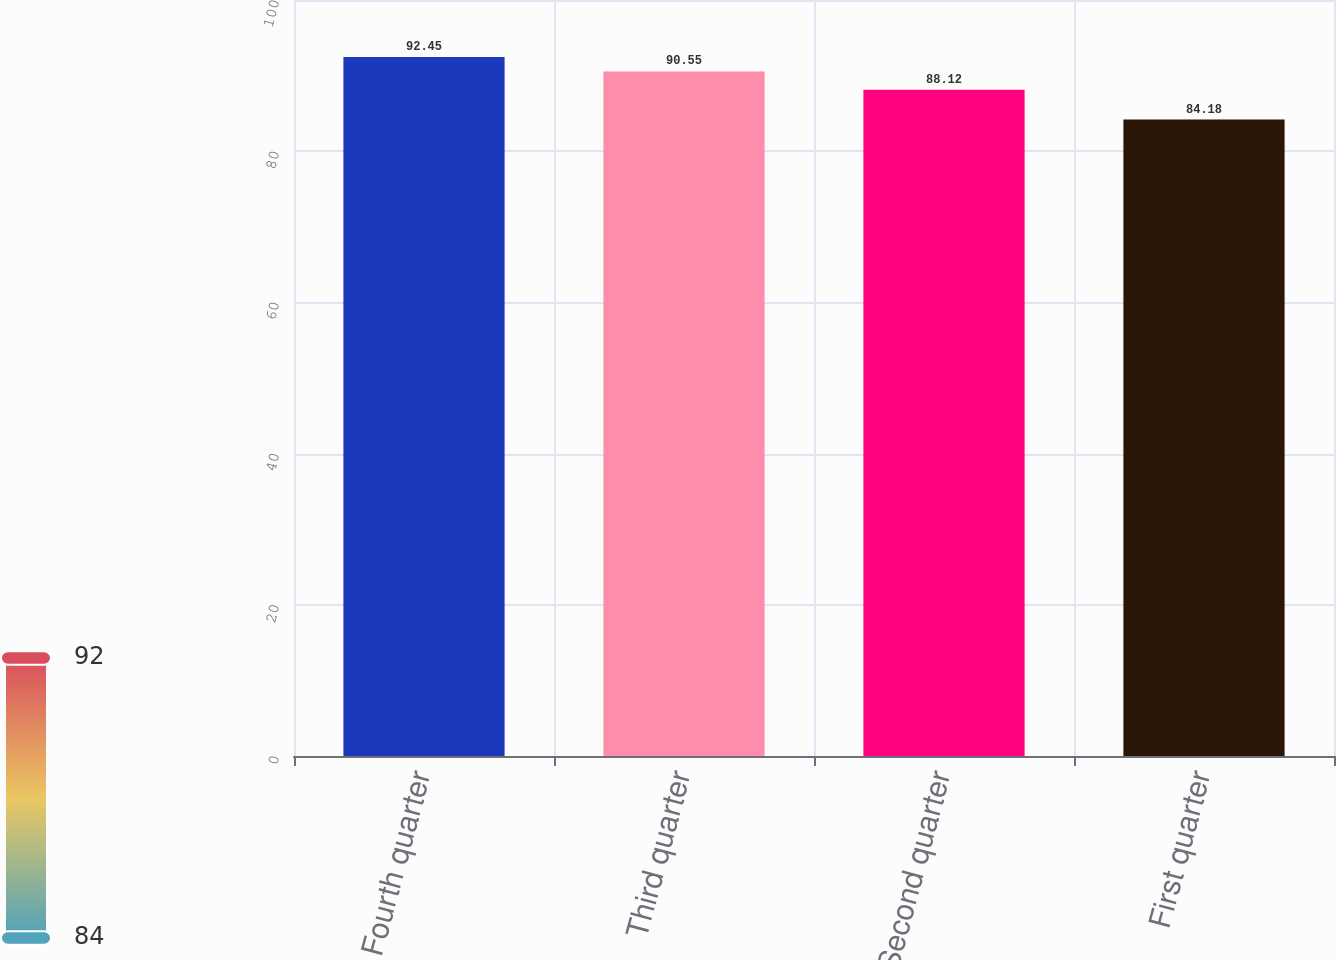Convert chart to OTSL. <chart><loc_0><loc_0><loc_500><loc_500><bar_chart><fcel>Fourth quarter<fcel>Third quarter<fcel>Second quarter<fcel>First quarter<nl><fcel>92.45<fcel>90.55<fcel>88.12<fcel>84.18<nl></chart> 